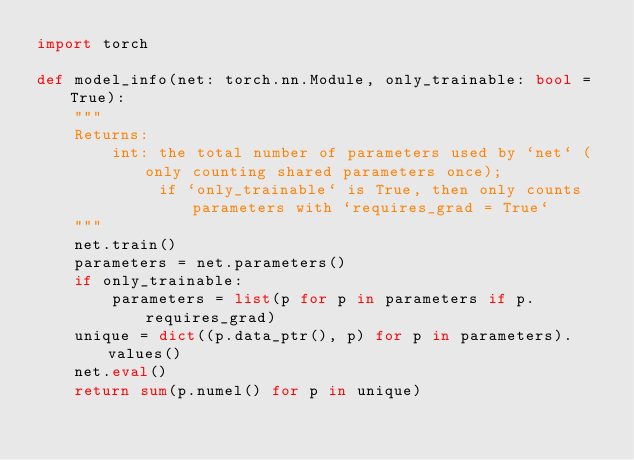<code> <loc_0><loc_0><loc_500><loc_500><_Python_>import torch

def model_info(net: torch.nn.Module, only_trainable: bool = True):
    """
    Returns:
        int: the total number of parameters used by `net` (only counting shared parameters once);
             if `only_trainable` is True, then only counts parameters with `requires_grad = True`
    """
    net.train()
    parameters = net.parameters()
    if only_trainable:
        parameters = list(p for p in parameters if p.requires_grad)
    unique = dict((p.data_ptr(), p) for p in parameters).values()
    net.eval()
    return sum(p.numel() for p in unique)
</code> 